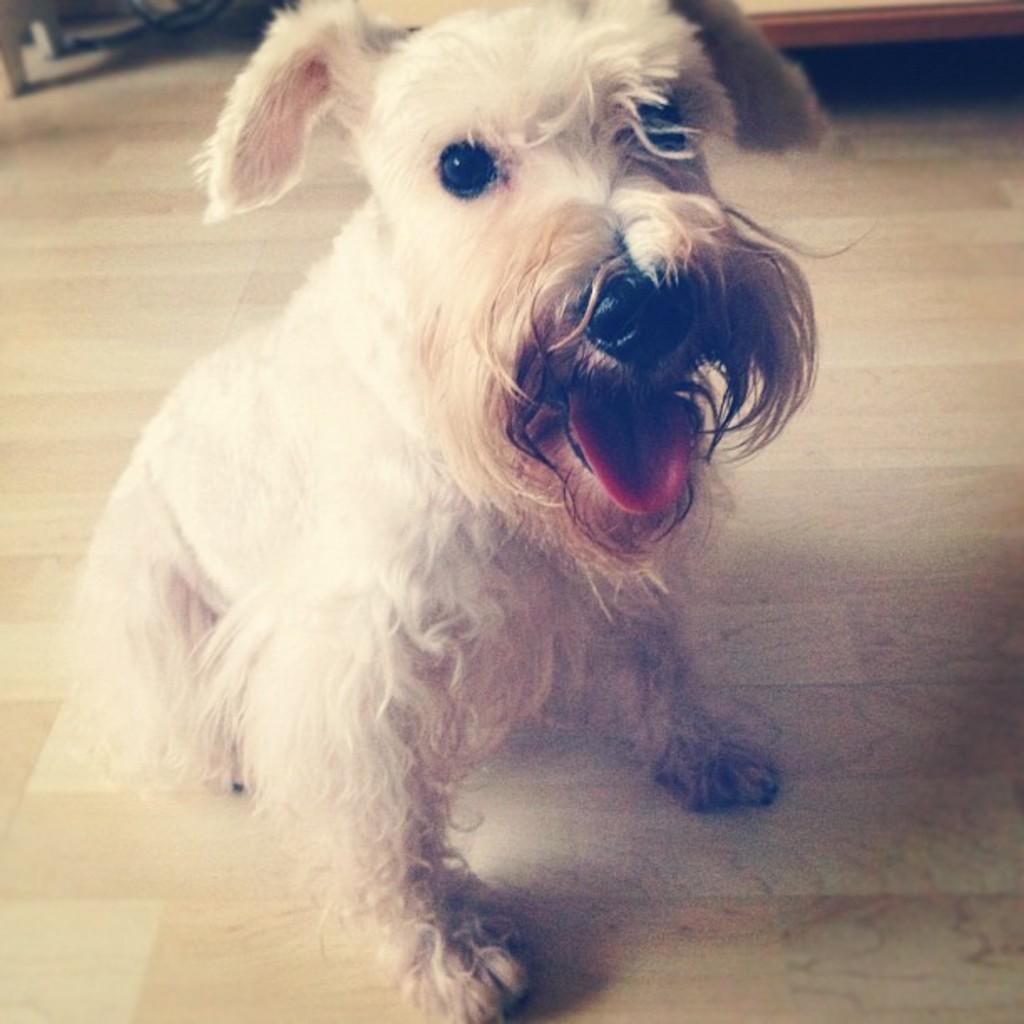What type of animal is in the image? There is a white color dog in the image. What is the dog doing in the image? The dog has its mouth opened. Where is the dog located in the image? The dog is on the floor. What else can be seen in the background of the image? There are other objects in the background of the image. How many trucks are rolling on the ground in the image? There are no trucks or rolling actions present in the image; it features a dog with its mouth opened on the floor. 